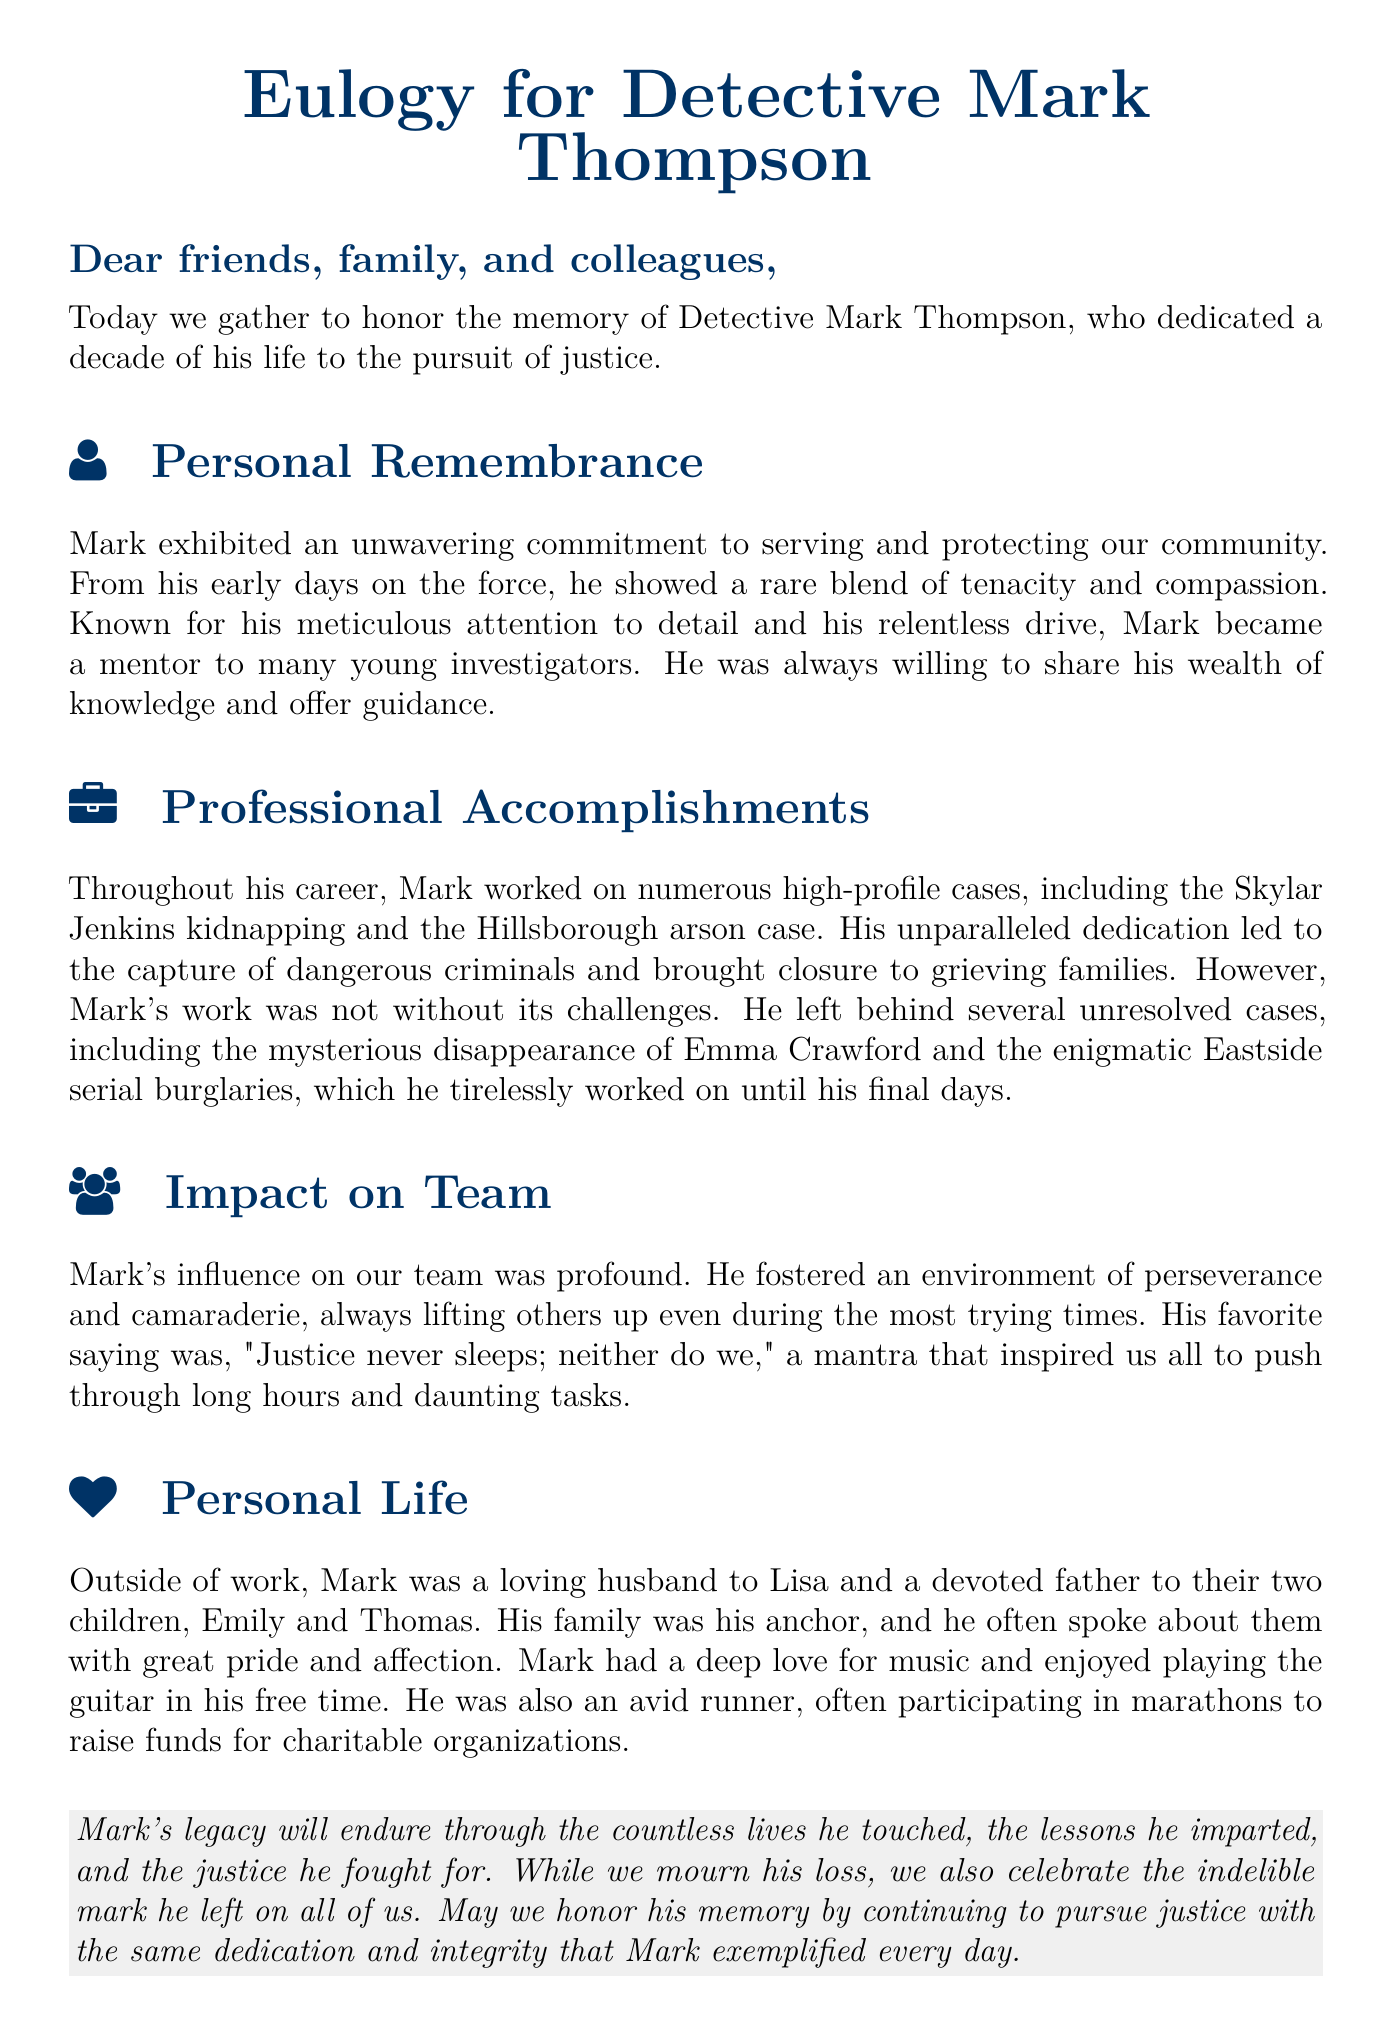What was Mark Thompson's profession? The eulogy states that Mark Thompson was a detective, highlighting his work with a commitment to justice.
Answer: Detective How many years did Mark Thompson dedicate to his career? The eulogy mentions that Mark Thompson dedicated a decade of his life to the pursuit of justice, indicating the total time spent in his career.
Answer: A decade Name one high-profile case Mark worked on. The document lists several high-profile cases that Mark worked on, specifically the Skylar Jenkins kidnapping as an example.
Answer: Skylar Jenkins kidnapping What was Mark's favorite saying? The eulogy includes Mark's favorite saying, which inspired his team during challenging times, indicating his philosophy regarding work.
Answer: "Justice never sleeps; neither do we" Who was Mark’s spouse? The document mentions that Mark was a loving husband to Lisa, providing information about his personal life and family.
Answer: Lisa What ongoing cases did Mark leave behind? The eulogy references unresolved cases that Mark worked on, naming the mysterious disappearance of Emma Crawford among others.
Answer: Mysterious disappearance of Emma Crawford What activity did Mark enjoy in his free time? The eulogy describes Mark as having a deep love for music and enjoying playing the guitar, showcasing his hobbies outside work.
Answer: Playing guitar What was Mark's impact on his team? The document emphasizes that Mark fostered an environment of perseverance and camaraderie, illustrating his positive influence on his colleagues.
Answer: Perseverance and camaraderie 